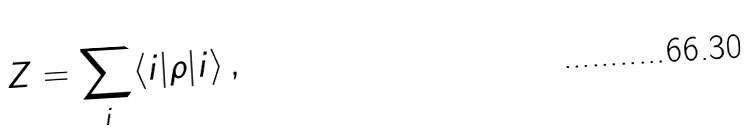<formula> <loc_0><loc_0><loc_500><loc_500>Z = \sum _ { i } \langle i | \rho | i \rangle \, ,</formula> 